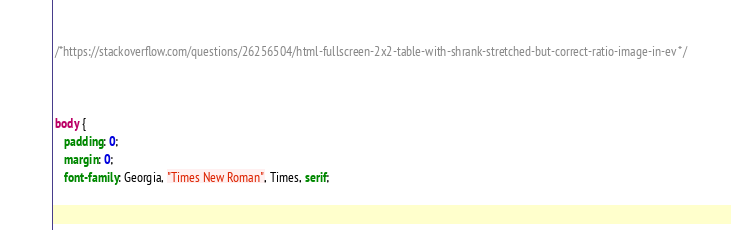<code> <loc_0><loc_0><loc_500><loc_500><_CSS_>
 /*https://stackoverflow.com/questions/26256504/html-fullscreen-2x2-table-with-shrank-stretched-but-correct-ratio-image-in-ev */
 
 

 body {
    padding: 0;
    margin: 0;
    font-family: Georgia, "Times New Roman", Times, serif;</code> 